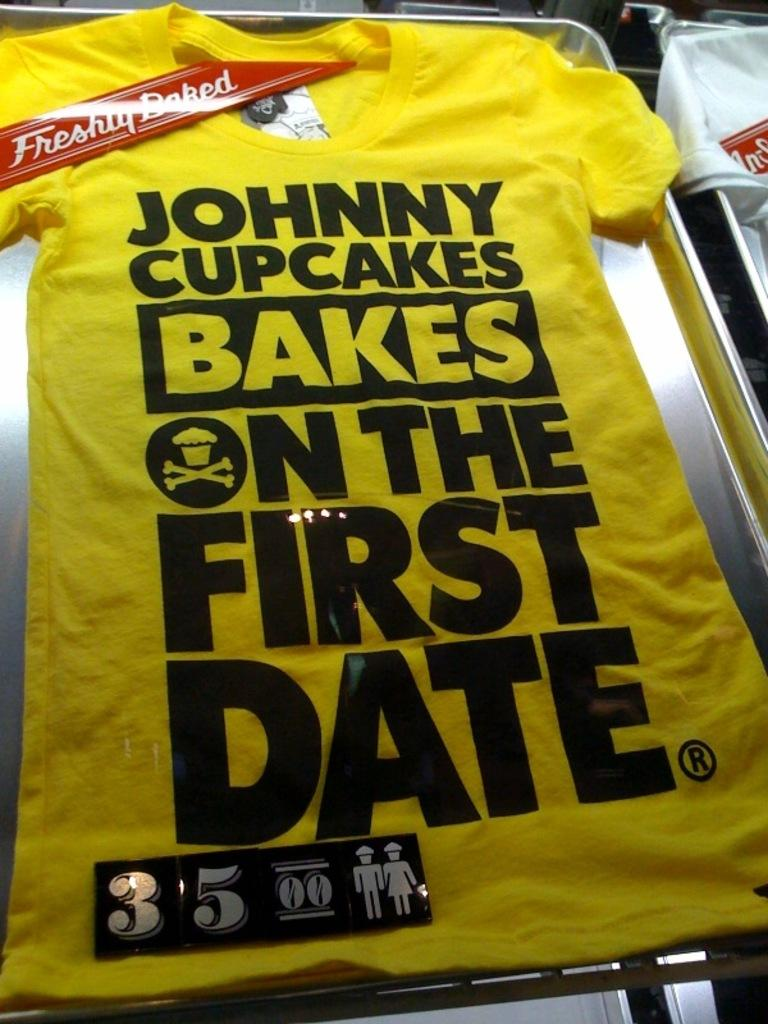<image>
Create a compact narrative representing the image presented. the yellow shirt for Johnny cupcakes is for sale 